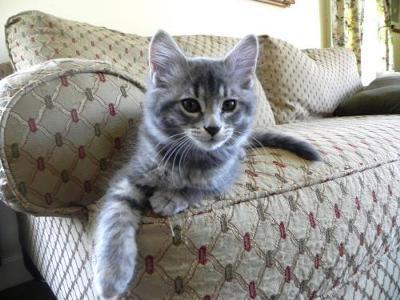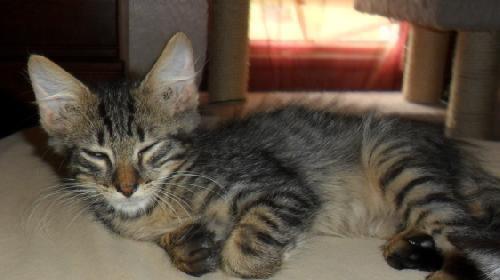The first image is the image on the left, the second image is the image on the right. Given the left and right images, does the statement "The left image shows a cat with open eyes reclining on soft furniture with pillows." hold true? Answer yes or no. Yes. The first image is the image on the left, the second image is the image on the right. Considering the images on both sides, is "The left and right image contains the same number of kittens." valid? Answer yes or no. Yes. 